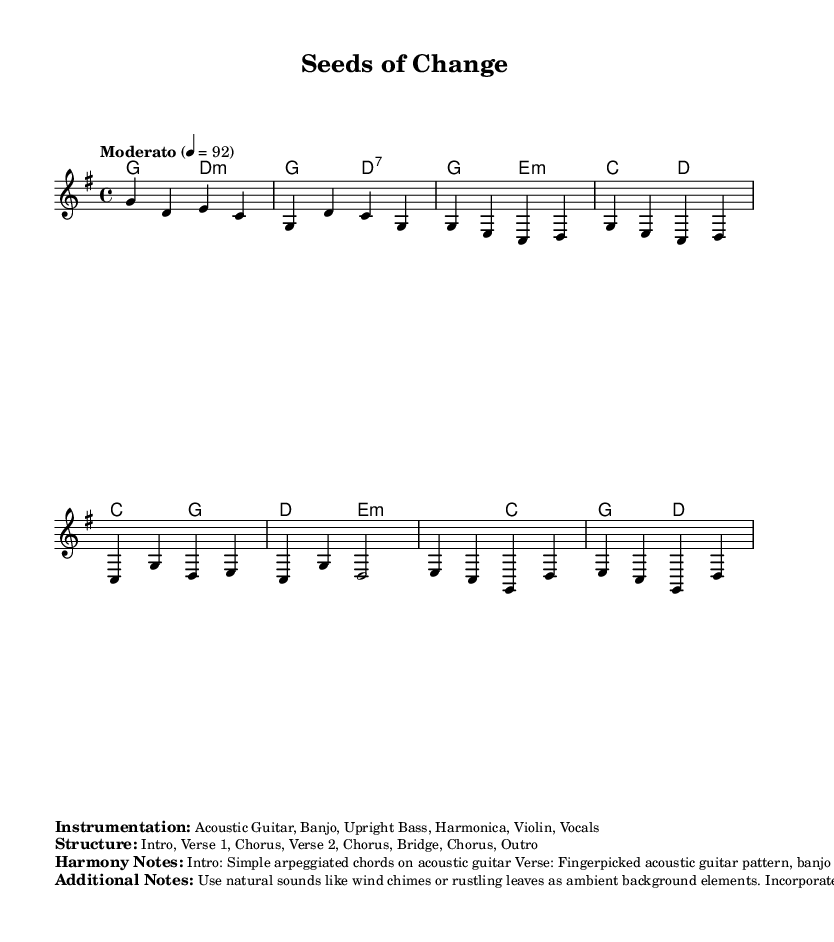What is the key signature of this music? The key signature is G major, indicated by one sharp (F#) at the beginning of the score.
Answer: G major What is the time signature of this piece? The time signature is 4/4, meaning there are four beats per measure, as shown at the beginning of the score.
Answer: 4/4 What is the tempo marking for this music? The tempo marking is "Moderato" and is set to 92 beats per minute, indicated at the start of the score.
Answer: Moderato, 92 What instruments are used in this piece? The instrumentation includes Acoustic Guitar, Banjo, Upright Bass, Harmonica, Violin, and Vocals, listed in the marked sections of the score.
Answer: Acoustic Guitar, Banjo, Upright Bass, Harmonica, Violin, Vocals How many sections are in the song structure? The structure outlined includes seven sections: Intro, Verse 1, Chorus, Verse 2, Chorus, Bridge, and Outro, totaling seven distinct parts.
Answer: Seven What style of harmony is featured in the verse? The verse features fingerpicked acoustic guitar patterns and banjo fills contributing to a folk feel, described in the harmony notes.
Answer: Fingerpicked acoustic guitar pattern, banjo fills What natural elements are suggested for ambient background? The score suggests using natural sounds like wind chimes or rustling leaves as ambient background elements, as noted in the additional notes.
Answer: Wind chimes, rustling leaves 